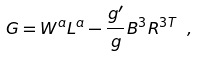Convert formula to latex. <formula><loc_0><loc_0><loc_500><loc_500>G = W ^ { a } L ^ { a } - \frac { g ^ { \prime } } { g } B ^ { 3 } R ^ { 3 T } \ ,</formula> 